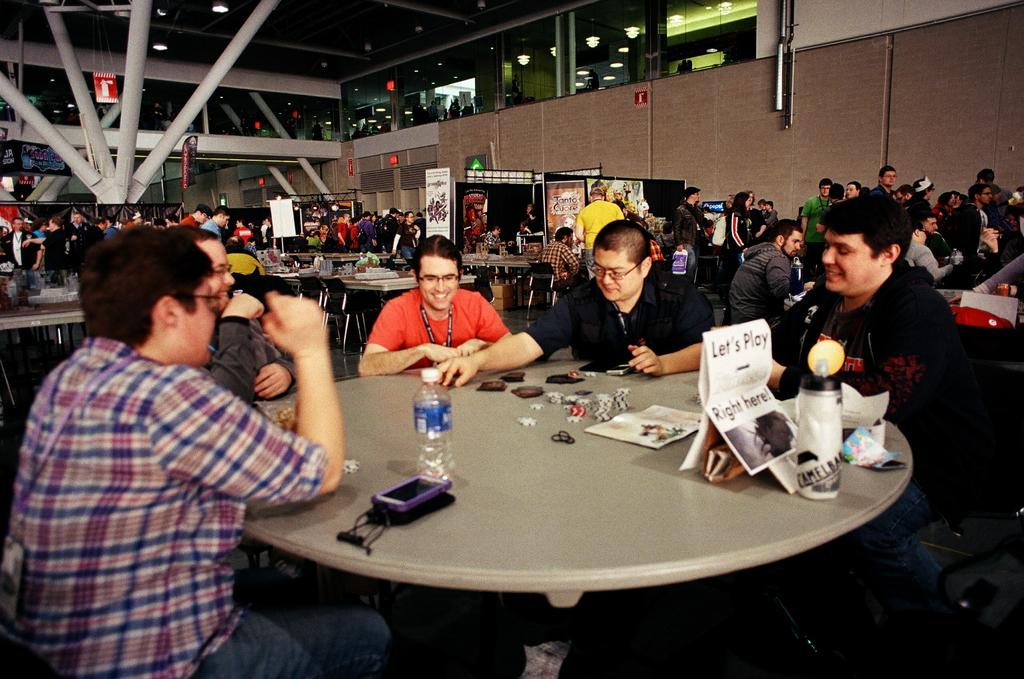How many people are in the image? There is a group of people in the image. What are the people doing in the image? The people are sitting on a chair in the image. Where is the chair located in relation to the table? The chair is in front of a table in the image. What can be seen on the table besides the chair? There is a glass bottle and other objects on the table in the image. What color is the vein in the image? There is no mention of a vein in the image, so it cannot be determined what color it might be. 